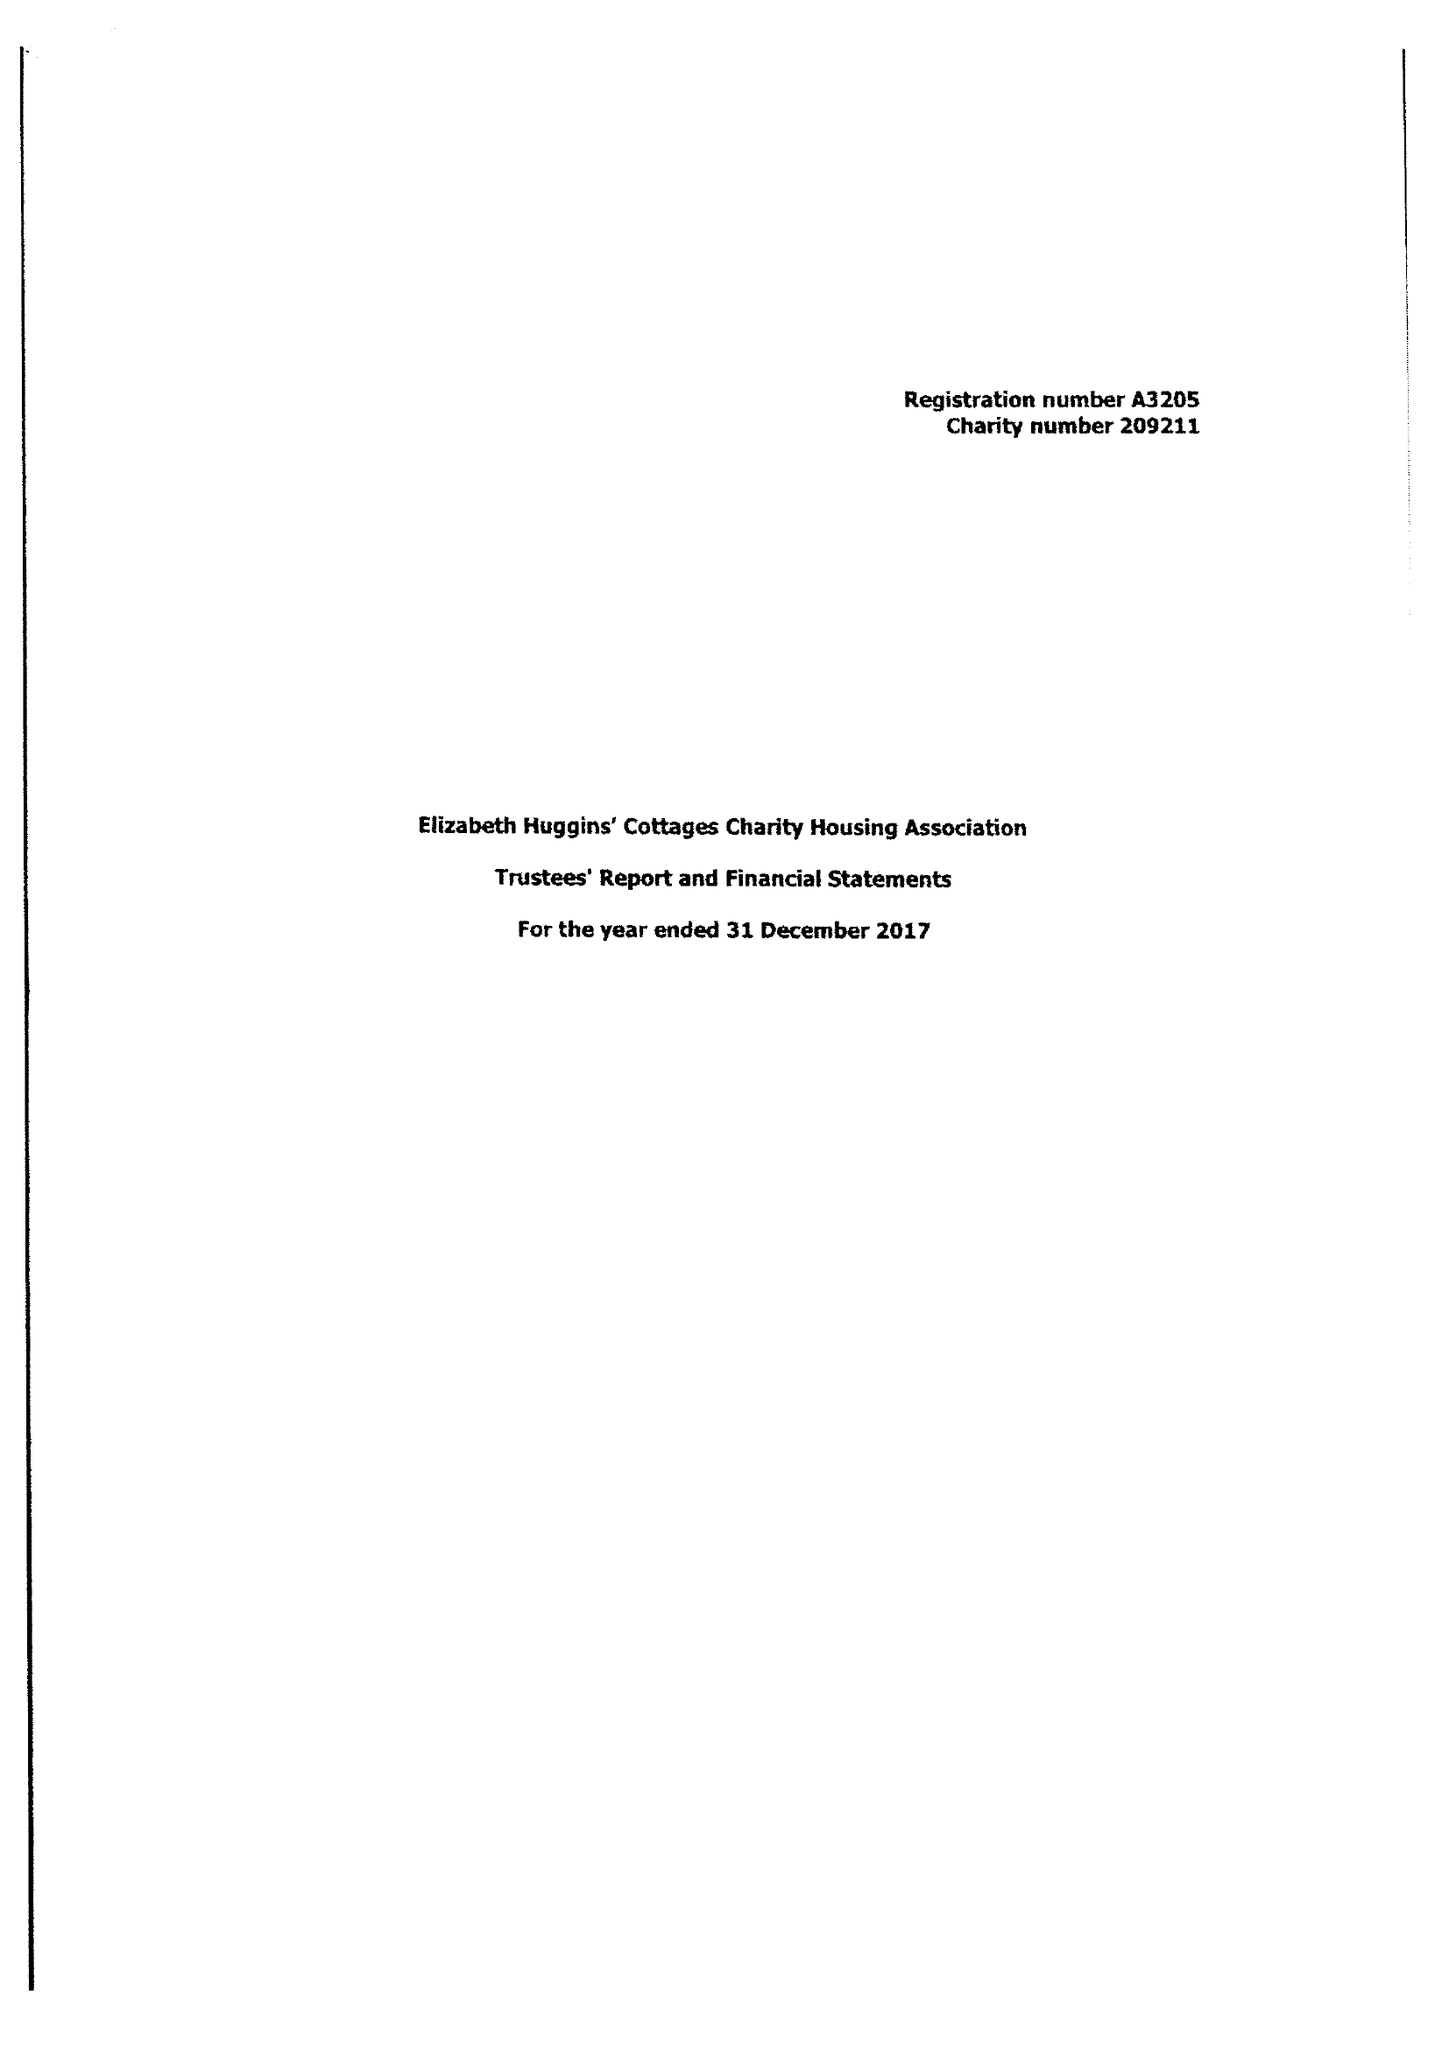What is the value for the charity_number?
Answer the question using a single word or phrase. 209211 